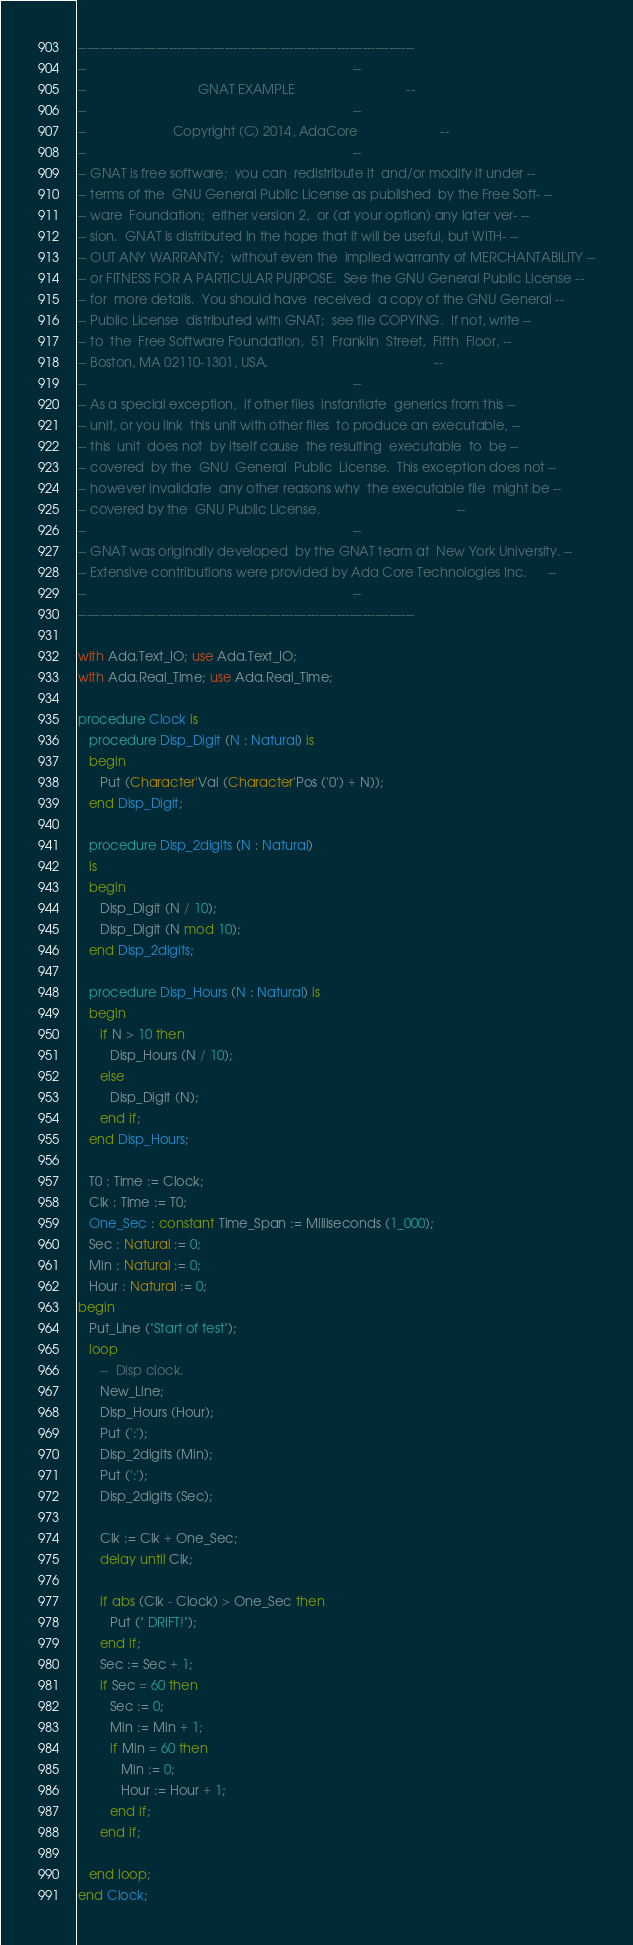Convert code to text. <code><loc_0><loc_0><loc_500><loc_500><_Ada_>------------------------------------------------------------------------------
--                                                                          --
--                               GNAT EXAMPLE                               --
--                                                                          --
--                        Copyright (C) 2014, AdaCore                       --
--                                                                          --
-- GNAT is free software;  you can  redistribute it  and/or modify it under --
-- terms of the  GNU General Public License as published  by the Free Soft- --
-- ware  Foundation;  either version 2,  or (at your option) any later ver- --
-- sion.  GNAT is distributed in the hope that it will be useful, but WITH- --
-- OUT ANY WARRANTY;  without even the  implied warranty of MERCHANTABILITY --
-- or FITNESS FOR A PARTICULAR PURPOSE.  See the GNU General Public License --
-- for  more details.  You should have  received  a copy of the GNU General --
-- Public License  distributed with GNAT;  see file COPYING.  If not, write --
-- to  the  Free Software Foundation,  51  Franklin  Street,  Fifth  Floor, --
-- Boston, MA 02110-1301, USA.                                              --
--                                                                          --
-- As a special exception,  if other files  instantiate  generics from this --
-- unit, or you link  this unit with other files  to produce an executable, --
-- this  unit  does not  by itself cause  the resulting  executable  to  be --
-- covered  by the  GNU  General  Public  License.  This exception does not --
-- however invalidate  any other reasons why  the executable file  might be --
-- covered by the  GNU Public License.                                      --
--                                                                          --
-- GNAT was originally developed  by the GNAT team at  New York University. --
-- Extensive contributions were provided by Ada Core Technologies Inc.      --
--                                                                          --
------------------------------------------------------------------------------

with Ada.Text_IO; use Ada.Text_IO;
with Ada.Real_Time; use Ada.Real_Time;

procedure Clock is
   procedure Disp_Digit (N : Natural) is
   begin
      Put (Character'Val (Character'Pos ('0') + N));
   end Disp_Digit;

   procedure Disp_2digits (N : Natural)
   is
   begin
      Disp_Digit (N / 10);
      Disp_Digit (N mod 10);
   end Disp_2digits;

   procedure Disp_Hours (N : Natural) is
   begin
      if N > 10 then
         Disp_Hours (N / 10);
      else
         Disp_Digit (N);
      end if;
   end Disp_Hours;

   T0 : Time := Clock;
   Clk : Time := T0;
   One_Sec : constant Time_Span := Milliseconds (1_000);
   Sec : Natural := 0;
   Min : Natural := 0;
   Hour : Natural := 0;
begin
   Put_Line ("Start of test");
   loop
      --  Disp clock.
      New_Line;
      Disp_Hours (Hour);
      Put (':');
      Disp_2digits (Min);
      Put (':');
      Disp_2digits (Sec);

      Clk := Clk + One_Sec;
      delay until Clk;

      if abs (Clk - Clock) > One_Sec then
         Put (" DRIFT!");
      end if;
      Sec := Sec + 1;
      if Sec = 60 then
         Sec := 0;
         Min := Min + 1;
         if Min = 60 then
            Min := 0;
            Hour := Hour + 1;
         end if;
      end if;

   end loop;
end Clock;
</code> 